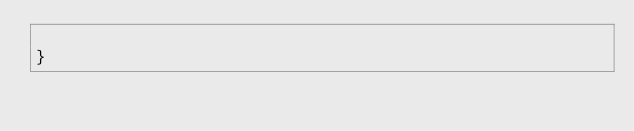Convert code to text. <code><loc_0><loc_0><loc_500><loc_500><_C++_>
}</code> 